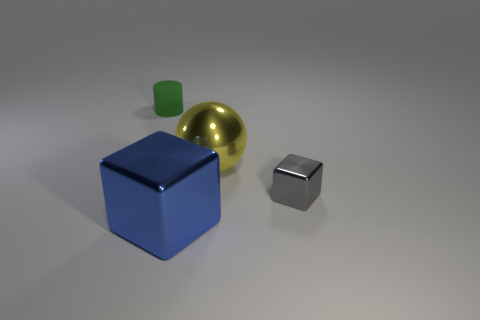Is there anything else that has the same color as the matte thing?
Your answer should be very brief. No. How many things are either things that are to the right of the green matte thing or large yellow rubber spheres?
Provide a short and direct response. 3. There is a object that is right of the yellow thing; is its size the same as the small green thing?
Make the answer very short. Yes. Is the number of small green objects in front of the large blue thing less than the number of small green cylinders?
Your answer should be very brief. Yes. There is a block that is the same size as the metallic sphere; what is its material?
Offer a very short reply. Metal. How many big things are either blue rubber cylinders or shiny things?
Make the answer very short. 2. What number of objects are either small things behind the gray object or metallic objects that are in front of the tiny shiny thing?
Ensure brevity in your answer.  2. Are there fewer blue cubes than cyan matte cylinders?
Your answer should be compact. No. What is the shape of the other metal object that is the same size as the blue shiny thing?
Your answer should be very brief. Sphere. How many other objects are the same color as the small rubber thing?
Offer a terse response. 0. 